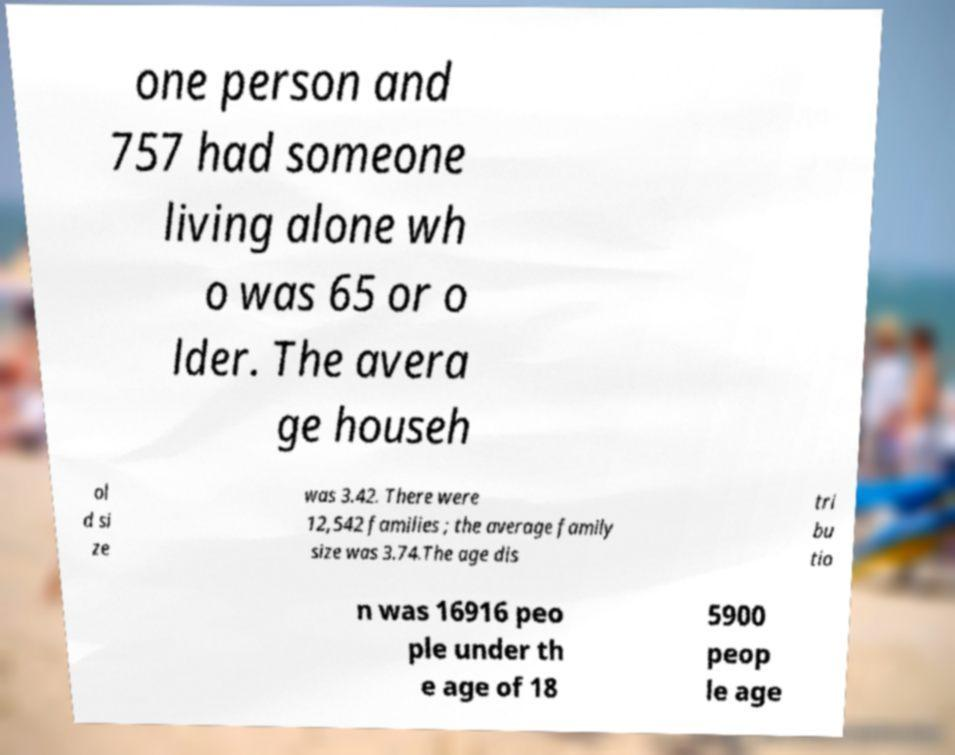For documentation purposes, I need the text within this image transcribed. Could you provide that? one person and 757 had someone living alone wh o was 65 or o lder. The avera ge househ ol d si ze was 3.42. There were 12,542 families ; the average family size was 3.74.The age dis tri bu tio n was 16916 peo ple under th e age of 18 5900 peop le age 